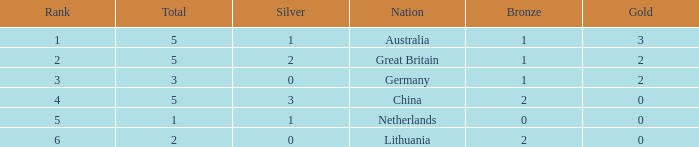What is the typical gold value when the rank is less than 3 and there are less than 1 bronze? None. 